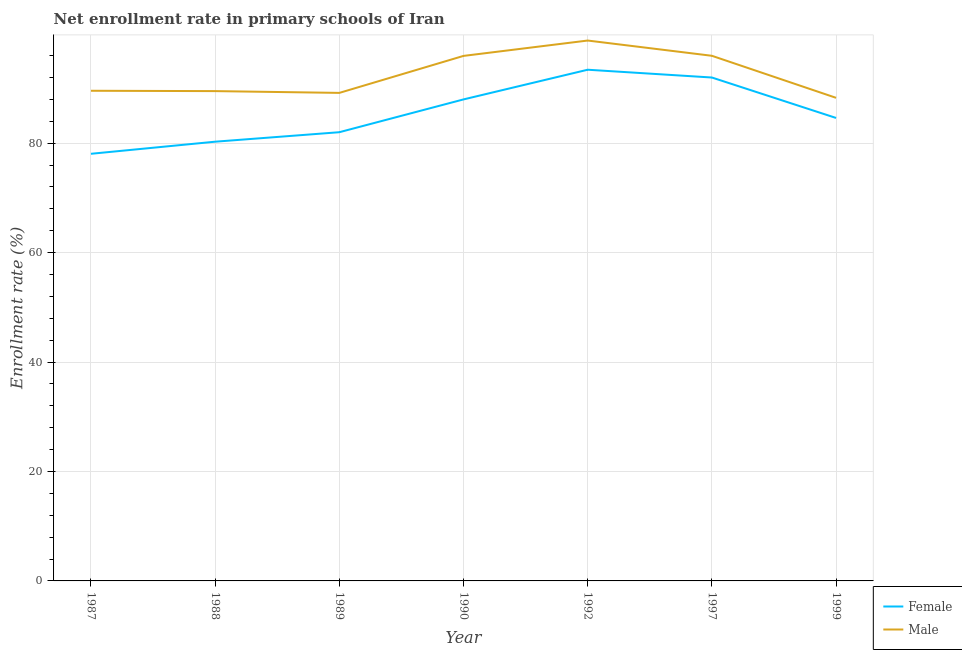Does the line corresponding to enrollment rate of male students intersect with the line corresponding to enrollment rate of female students?
Offer a terse response. No. What is the enrollment rate of female students in 1988?
Your answer should be compact. 80.26. Across all years, what is the maximum enrollment rate of male students?
Keep it short and to the point. 98.75. Across all years, what is the minimum enrollment rate of male students?
Keep it short and to the point. 88.28. In which year was the enrollment rate of male students minimum?
Keep it short and to the point. 1999. What is the total enrollment rate of male students in the graph?
Offer a terse response. 647.19. What is the difference between the enrollment rate of male students in 1987 and that in 1989?
Give a very brief answer. 0.39. What is the difference between the enrollment rate of female students in 1989 and the enrollment rate of male students in 1999?
Give a very brief answer. -6.28. What is the average enrollment rate of female students per year?
Make the answer very short. 85.47. In the year 1987, what is the difference between the enrollment rate of female students and enrollment rate of male students?
Offer a terse response. -11.52. What is the ratio of the enrollment rate of female students in 1988 to that in 1989?
Give a very brief answer. 0.98. Is the difference between the enrollment rate of male students in 1990 and 1997 greater than the difference between the enrollment rate of female students in 1990 and 1997?
Your answer should be very brief. Yes. What is the difference between the highest and the second highest enrollment rate of female students?
Your response must be concise. 1.42. What is the difference between the highest and the lowest enrollment rate of male students?
Make the answer very short. 10.47. In how many years, is the enrollment rate of female students greater than the average enrollment rate of female students taken over all years?
Keep it short and to the point. 3. Is the enrollment rate of female students strictly greater than the enrollment rate of male students over the years?
Your response must be concise. No. How many lines are there?
Give a very brief answer. 2. How many years are there in the graph?
Ensure brevity in your answer.  7. What is the difference between two consecutive major ticks on the Y-axis?
Give a very brief answer. 20. Does the graph contain any zero values?
Ensure brevity in your answer.  No. Where does the legend appear in the graph?
Ensure brevity in your answer.  Bottom right. How are the legend labels stacked?
Make the answer very short. Vertical. What is the title of the graph?
Provide a succinct answer. Net enrollment rate in primary schools of Iran. Does "Personal remittances" appear as one of the legend labels in the graph?
Offer a very short reply. No. What is the label or title of the X-axis?
Provide a succinct answer. Year. What is the label or title of the Y-axis?
Offer a very short reply. Enrollment rate (%). What is the Enrollment rate (%) of Female in 1987?
Give a very brief answer. 78.05. What is the Enrollment rate (%) of Male in 1987?
Make the answer very short. 89.57. What is the Enrollment rate (%) of Female in 1988?
Ensure brevity in your answer.  80.26. What is the Enrollment rate (%) of Male in 1988?
Keep it short and to the point. 89.51. What is the Enrollment rate (%) of Female in 1989?
Give a very brief answer. 82. What is the Enrollment rate (%) of Male in 1989?
Offer a terse response. 89.18. What is the Enrollment rate (%) in Female in 1990?
Provide a succinct answer. 87.99. What is the Enrollment rate (%) of Male in 1990?
Offer a terse response. 95.94. What is the Enrollment rate (%) of Female in 1992?
Your answer should be very brief. 93.41. What is the Enrollment rate (%) in Male in 1992?
Make the answer very short. 98.75. What is the Enrollment rate (%) in Female in 1997?
Your answer should be compact. 91.99. What is the Enrollment rate (%) in Male in 1997?
Provide a succinct answer. 95.96. What is the Enrollment rate (%) of Female in 1999?
Provide a short and direct response. 84.6. What is the Enrollment rate (%) of Male in 1999?
Provide a short and direct response. 88.28. Across all years, what is the maximum Enrollment rate (%) in Female?
Your answer should be very brief. 93.41. Across all years, what is the maximum Enrollment rate (%) in Male?
Your answer should be very brief. 98.75. Across all years, what is the minimum Enrollment rate (%) of Female?
Give a very brief answer. 78.05. Across all years, what is the minimum Enrollment rate (%) of Male?
Make the answer very short. 88.28. What is the total Enrollment rate (%) of Female in the graph?
Your answer should be compact. 598.31. What is the total Enrollment rate (%) of Male in the graph?
Offer a terse response. 647.19. What is the difference between the Enrollment rate (%) of Female in 1987 and that in 1988?
Provide a succinct answer. -2.21. What is the difference between the Enrollment rate (%) in Male in 1987 and that in 1988?
Your response must be concise. 0.06. What is the difference between the Enrollment rate (%) of Female in 1987 and that in 1989?
Your answer should be compact. -3.94. What is the difference between the Enrollment rate (%) in Male in 1987 and that in 1989?
Offer a very short reply. 0.39. What is the difference between the Enrollment rate (%) of Female in 1987 and that in 1990?
Your answer should be very brief. -9.94. What is the difference between the Enrollment rate (%) of Male in 1987 and that in 1990?
Your response must be concise. -6.37. What is the difference between the Enrollment rate (%) of Female in 1987 and that in 1992?
Your response must be concise. -15.36. What is the difference between the Enrollment rate (%) of Male in 1987 and that in 1992?
Ensure brevity in your answer.  -9.18. What is the difference between the Enrollment rate (%) of Female in 1987 and that in 1997?
Give a very brief answer. -13.94. What is the difference between the Enrollment rate (%) in Male in 1987 and that in 1997?
Ensure brevity in your answer.  -6.39. What is the difference between the Enrollment rate (%) of Female in 1987 and that in 1999?
Your response must be concise. -6.55. What is the difference between the Enrollment rate (%) of Male in 1987 and that in 1999?
Give a very brief answer. 1.29. What is the difference between the Enrollment rate (%) in Female in 1988 and that in 1989?
Provide a short and direct response. -1.73. What is the difference between the Enrollment rate (%) of Male in 1988 and that in 1989?
Your response must be concise. 0.33. What is the difference between the Enrollment rate (%) of Female in 1988 and that in 1990?
Your response must be concise. -7.73. What is the difference between the Enrollment rate (%) of Male in 1988 and that in 1990?
Your answer should be very brief. -6.43. What is the difference between the Enrollment rate (%) in Female in 1988 and that in 1992?
Give a very brief answer. -13.15. What is the difference between the Enrollment rate (%) of Male in 1988 and that in 1992?
Provide a short and direct response. -9.24. What is the difference between the Enrollment rate (%) in Female in 1988 and that in 1997?
Make the answer very short. -11.73. What is the difference between the Enrollment rate (%) of Male in 1988 and that in 1997?
Your answer should be compact. -6.45. What is the difference between the Enrollment rate (%) in Female in 1988 and that in 1999?
Offer a very short reply. -4.34. What is the difference between the Enrollment rate (%) of Male in 1988 and that in 1999?
Your answer should be very brief. 1.23. What is the difference between the Enrollment rate (%) of Female in 1989 and that in 1990?
Provide a short and direct response. -5.99. What is the difference between the Enrollment rate (%) in Male in 1989 and that in 1990?
Make the answer very short. -6.76. What is the difference between the Enrollment rate (%) of Female in 1989 and that in 1992?
Offer a terse response. -11.42. What is the difference between the Enrollment rate (%) in Male in 1989 and that in 1992?
Make the answer very short. -9.57. What is the difference between the Enrollment rate (%) in Female in 1989 and that in 1997?
Your answer should be compact. -10. What is the difference between the Enrollment rate (%) of Male in 1989 and that in 1997?
Keep it short and to the point. -6.78. What is the difference between the Enrollment rate (%) of Female in 1989 and that in 1999?
Ensure brevity in your answer.  -2.6. What is the difference between the Enrollment rate (%) of Male in 1989 and that in 1999?
Your response must be concise. 0.9. What is the difference between the Enrollment rate (%) in Female in 1990 and that in 1992?
Offer a terse response. -5.43. What is the difference between the Enrollment rate (%) in Male in 1990 and that in 1992?
Give a very brief answer. -2.81. What is the difference between the Enrollment rate (%) of Female in 1990 and that in 1997?
Offer a very short reply. -4. What is the difference between the Enrollment rate (%) of Male in 1990 and that in 1997?
Your answer should be very brief. -0.02. What is the difference between the Enrollment rate (%) of Female in 1990 and that in 1999?
Your response must be concise. 3.39. What is the difference between the Enrollment rate (%) of Male in 1990 and that in 1999?
Offer a terse response. 7.66. What is the difference between the Enrollment rate (%) of Female in 1992 and that in 1997?
Ensure brevity in your answer.  1.42. What is the difference between the Enrollment rate (%) of Male in 1992 and that in 1997?
Make the answer very short. 2.79. What is the difference between the Enrollment rate (%) in Female in 1992 and that in 1999?
Provide a short and direct response. 8.81. What is the difference between the Enrollment rate (%) in Male in 1992 and that in 1999?
Your response must be concise. 10.47. What is the difference between the Enrollment rate (%) of Female in 1997 and that in 1999?
Offer a very short reply. 7.39. What is the difference between the Enrollment rate (%) of Male in 1997 and that in 1999?
Keep it short and to the point. 7.68. What is the difference between the Enrollment rate (%) of Female in 1987 and the Enrollment rate (%) of Male in 1988?
Give a very brief answer. -11.45. What is the difference between the Enrollment rate (%) of Female in 1987 and the Enrollment rate (%) of Male in 1989?
Your answer should be compact. -11.13. What is the difference between the Enrollment rate (%) in Female in 1987 and the Enrollment rate (%) in Male in 1990?
Your answer should be very brief. -17.89. What is the difference between the Enrollment rate (%) in Female in 1987 and the Enrollment rate (%) in Male in 1992?
Give a very brief answer. -20.7. What is the difference between the Enrollment rate (%) of Female in 1987 and the Enrollment rate (%) of Male in 1997?
Your answer should be very brief. -17.91. What is the difference between the Enrollment rate (%) in Female in 1987 and the Enrollment rate (%) in Male in 1999?
Your answer should be very brief. -10.23. What is the difference between the Enrollment rate (%) of Female in 1988 and the Enrollment rate (%) of Male in 1989?
Offer a very short reply. -8.92. What is the difference between the Enrollment rate (%) of Female in 1988 and the Enrollment rate (%) of Male in 1990?
Provide a short and direct response. -15.68. What is the difference between the Enrollment rate (%) of Female in 1988 and the Enrollment rate (%) of Male in 1992?
Your answer should be compact. -18.48. What is the difference between the Enrollment rate (%) in Female in 1988 and the Enrollment rate (%) in Male in 1997?
Your answer should be compact. -15.7. What is the difference between the Enrollment rate (%) in Female in 1988 and the Enrollment rate (%) in Male in 1999?
Your answer should be very brief. -8.02. What is the difference between the Enrollment rate (%) in Female in 1989 and the Enrollment rate (%) in Male in 1990?
Give a very brief answer. -13.94. What is the difference between the Enrollment rate (%) of Female in 1989 and the Enrollment rate (%) of Male in 1992?
Keep it short and to the point. -16.75. What is the difference between the Enrollment rate (%) of Female in 1989 and the Enrollment rate (%) of Male in 1997?
Your response must be concise. -13.96. What is the difference between the Enrollment rate (%) of Female in 1989 and the Enrollment rate (%) of Male in 1999?
Make the answer very short. -6.28. What is the difference between the Enrollment rate (%) of Female in 1990 and the Enrollment rate (%) of Male in 1992?
Provide a short and direct response. -10.76. What is the difference between the Enrollment rate (%) in Female in 1990 and the Enrollment rate (%) in Male in 1997?
Give a very brief answer. -7.97. What is the difference between the Enrollment rate (%) in Female in 1990 and the Enrollment rate (%) in Male in 1999?
Provide a short and direct response. -0.29. What is the difference between the Enrollment rate (%) in Female in 1992 and the Enrollment rate (%) in Male in 1997?
Provide a short and direct response. -2.55. What is the difference between the Enrollment rate (%) of Female in 1992 and the Enrollment rate (%) of Male in 1999?
Your response must be concise. 5.13. What is the difference between the Enrollment rate (%) in Female in 1997 and the Enrollment rate (%) in Male in 1999?
Make the answer very short. 3.71. What is the average Enrollment rate (%) of Female per year?
Give a very brief answer. 85.47. What is the average Enrollment rate (%) of Male per year?
Your response must be concise. 92.46. In the year 1987, what is the difference between the Enrollment rate (%) in Female and Enrollment rate (%) in Male?
Make the answer very short. -11.52. In the year 1988, what is the difference between the Enrollment rate (%) of Female and Enrollment rate (%) of Male?
Keep it short and to the point. -9.24. In the year 1989, what is the difference between the Enrollment rate (%) in Female and Enrollment rate (%) in Male?
Your answer should be very brief. -7.18. In the year 1990, what is the difference between the Enrollment rate (%) in Female and Enrollment rate (%) in Male?
Keep it short and to the point. -7.95. In the year 1992, what is the difference between the Enrollment rate (%) of Female and Enrollment rate (%) of Male?
Ensure brevity in your answer.  -5.33. In the year 1997, what is the difference between the Enrollment rate (%) of Female and Enrollment rate (%) of Male?
Offer a terse response. -3.97. In the year 1999, what is the difference between the Enrollment rate (%) of Female and Enrollment rate (%) of Male?
Your response must be concise. -3.68. What is the ratio of the Enrollment rate (%) in Female in 1987 to that in 1988?
Your answer should be very brief. 0.97. What is the ratio of the Enrollment rate (%) of Female in 1987 to that in 1989?
Provide a short and direct response. 0.95. What is the ratio of the Enrollment rate (%) of Female in 1987 to that in 1990?
Offer a very short reply. 0.89. What is the ratio of the Enrollment rate (%) in Male in 1987 to that in 1990?
Ensure brevity in your answer.  0.93. What is the ratio of the Enrollment rate (%) of Female in 1987 to that in 1992?
Your answer should be compact. 0.84. What is the ratio of the Enrollment rate (%) in Male in 1987 to that in 1992?
Offer a very short reply. 0.91. What is the ratio of the Enrollment rate (%) of Female in 1987 to that in 1997?
Your answer should be compact. 0.85. What is the ratio of the Enrollment rate (%) in Male in 1987 to that in 1997?
Offer a very short reply. 0.93. What is the ratio of the Enrollment rate (%) of Female in 1987 to that in 1999?
Your answer should be very brief. 0.92. What is the ratio of the Enrollment rate (%) of Male in 1987 to that in 1999?
Ensure brevity in your answer.  1.01. What is the ratio of the Enrollment rate (%) of Female in 1988 to that in 1989?
Offer a very short reply. 0.98. What is the ratio of the Enrollment rate (%) in Male in 1988 to that in 1989?
Provide a succinct answer. 1. What is the ratio of the Enrollment rate (%) of Female in 1988 to that in 1990?
Offer a very short reply. 0.91. What is the ratio of the Enrollment rate (%) in Male in 1988 to that in 1990?
Provide a short and direct response. 0.93. What is the ratio of the Enrollment rate (%) in Female in 1988 to that in 1992?
Ensure brevity in your answer.  0.86. What is the ratio of the Enrollment rate (%) of Male in 1988 to that in 1992?
Your response must be concise. 0.91. What is the ratio of the Enrollment rate (%) in Female in 1988 to that in 1997?
Your response must be concise. 0.87. What is the ratio of the Enrollment rate (%) in Male in 1988 to that in 1997?
Your answer should be compact. 0.93. What is the ratio of the Enrollment rate (%) of Female in 1988 to that in 1999?
Provide a short and direct response. 0.95. What is the ratio of the Enrollment rate (%) in Male in 1988 to that in 1999?
Keep it short and to the point. 1.01. What is the ratio of the Enrollment rate (%) of Female in 1989 to that in 1990?
Your answer should be compact. 0.93. What is the ratio of the Enrollment rate (%) in Male in 1989 to that in 1990?
Your answer should be very brief. 0.93. What is the ratio of the Enrollment rate (%) in Female in 1989 to that in 1992?
Keep it short and to the point. 0.88. What is the ratio of the Enrollment rate (%) of Male in 1989 to that in 1992?
Offer a terse response. 0.9. What is the ratio of the Enrollment rate (%) of Female in 1989 to that in 1997?
Ensure brevity in your answer.  0.89. What is the ratio of the Enrollment rate (%) of Male in 1989 to that in 1997?
Your response must be concise. 0.93. What is the ratio of the Enrollment rate (%) of Female in 1989 to that in 1999?
Offer a terse response. 0.97. What is the ratio of the Enrollment rate (%) of Male in 1989 to that in 1999?
Offer a very short reply. 1.01. What is the ratio of the Enrollment rate (%) in Female in 1990 to that in 1992?
Provide a succinct answer. 0.94. What is the ratio of the Enrollment rate (%) of Male in 1990 to that in 1992?
Provide a short and direct response. 0.97. What is the ratio of the Enrollment rate (%) of Female in 1990 to that in 1997?
Keep it short and to the point. 0.96. What is the ratio of the Enrollment rate (%) of Male in 1990 to that in 1999?
Offer a terse response. 1.09. What is the ratio of the Enrollment rate (%) in Female in 1992 to that in 1997?
Provide a short and direct response. 1.02. What is the ratio of the Enrollment rate (%) in Male in 1992 to that in 1997?
Provide a succinct answer. 1.03. What is the ratio of the Enrollment rate (%) of Female in 1992 to that in 1999?
Your answer should be compact. 1.1. What is the ratio of the Enrollment rate (%) of Male in 1992 to that in 1999?
Make the answer very short. 1.12. What is the ratio of the Enrollment rate (%) in Female in 1997 to that in 1999?
Provide a succinct answer. 1.09. What is the ratio of the Enrollment rate (%) in Male in 1997 to that in 1999?
Offer a very short reply. 1.09. What is the difference between the highest and the second highest Enrollment rate (%) of Female?
Offer a very short reply. 1.42. What is the difference between the highest and the second highest Enrollment rate (%) in Male?
Offer a very short reply. 2.79. What is the difference between the highest and the lowest Enrollment rate (%) in Female?
Give a very brief answer. 15.36. What is the difference between the highest and the lowest Enrollment rate (%) of Male?
Offer a very short reply. 10.47. 